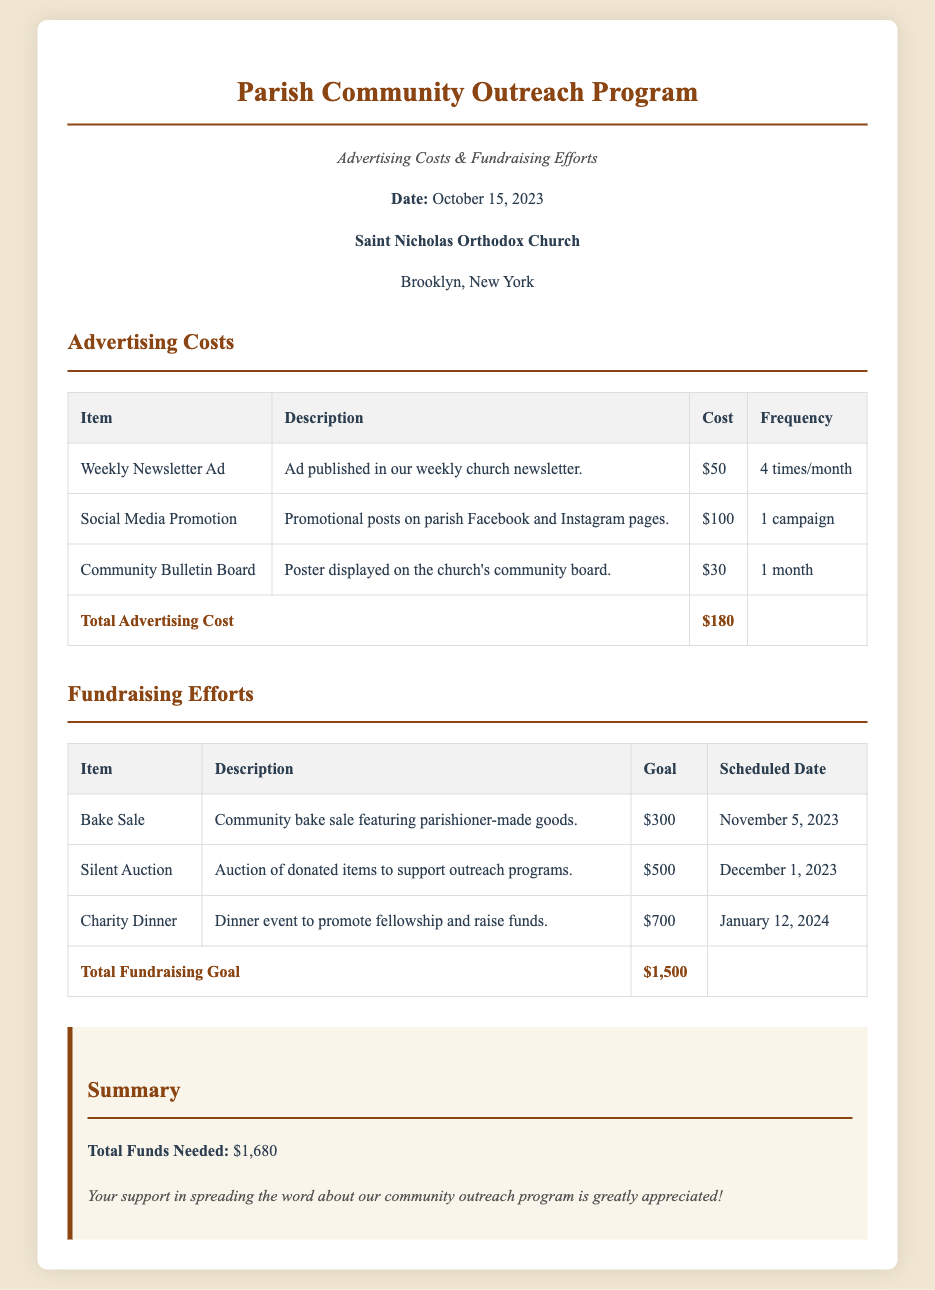What is the date of the bill? The date listed in the document is October 15, 2023.
Answer: October 15, 2023 What is the total advertising cost? The total advertising cost is summed from the individual advertising items, which equals $180.
Answer: $180 How much is the goal for the Charity Dinner? The goal for the Charity Dinner is stated in the fundraising efforts section, which is $700.
Answer: $700 What type of event is scheduled for November 5, 2023? The event on November 5, 2023, is a Bake Sale, as indicated in the fundraising efforts table.
Answer: Bake Sale What is the total amount of funds needed for the outreach program? The total funds needed is calculated as the sum of total advertising cost and total fundraising goal, which is $1,680.
Answer: $1,680 What advertising item costs $50? The advertising item costing $50 is the Weekly Newsletter Ad according to the advertising costs table.
Answer: Weekly Newsletter Ad How many times will the Weekly Newsletter Ad be published? The frequency mentioned for the Weekly Newsletter Ad is four times a month.
Answer: 4 times/month What is the description of the Silent Auction? The description of the Silent Auction is provided in the fundraising efforts section, stating it is to auction donated items to support outreach programs.
Answer: Auction of donated items to support outreach programs 